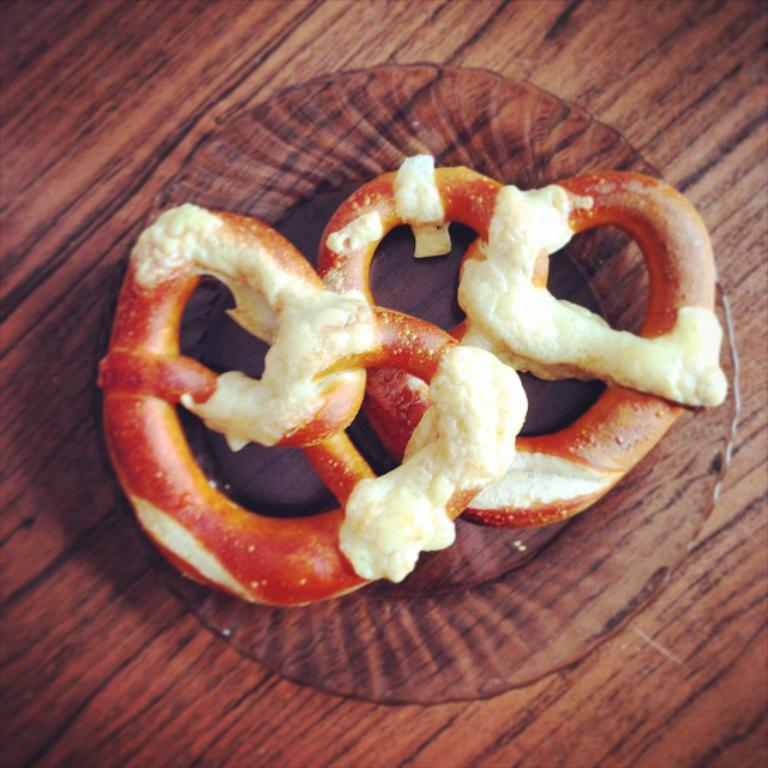What is the main piece of furniture in the image? There is a table in the image. What is placed on the table? There is a bowl on the table. What type of food can be seen in the bowl? A: There are two pretzels in the bowl. What type of flowers are in the vase on the table in the image? There is no vase present in the image, so it is not possible to answer that question. 